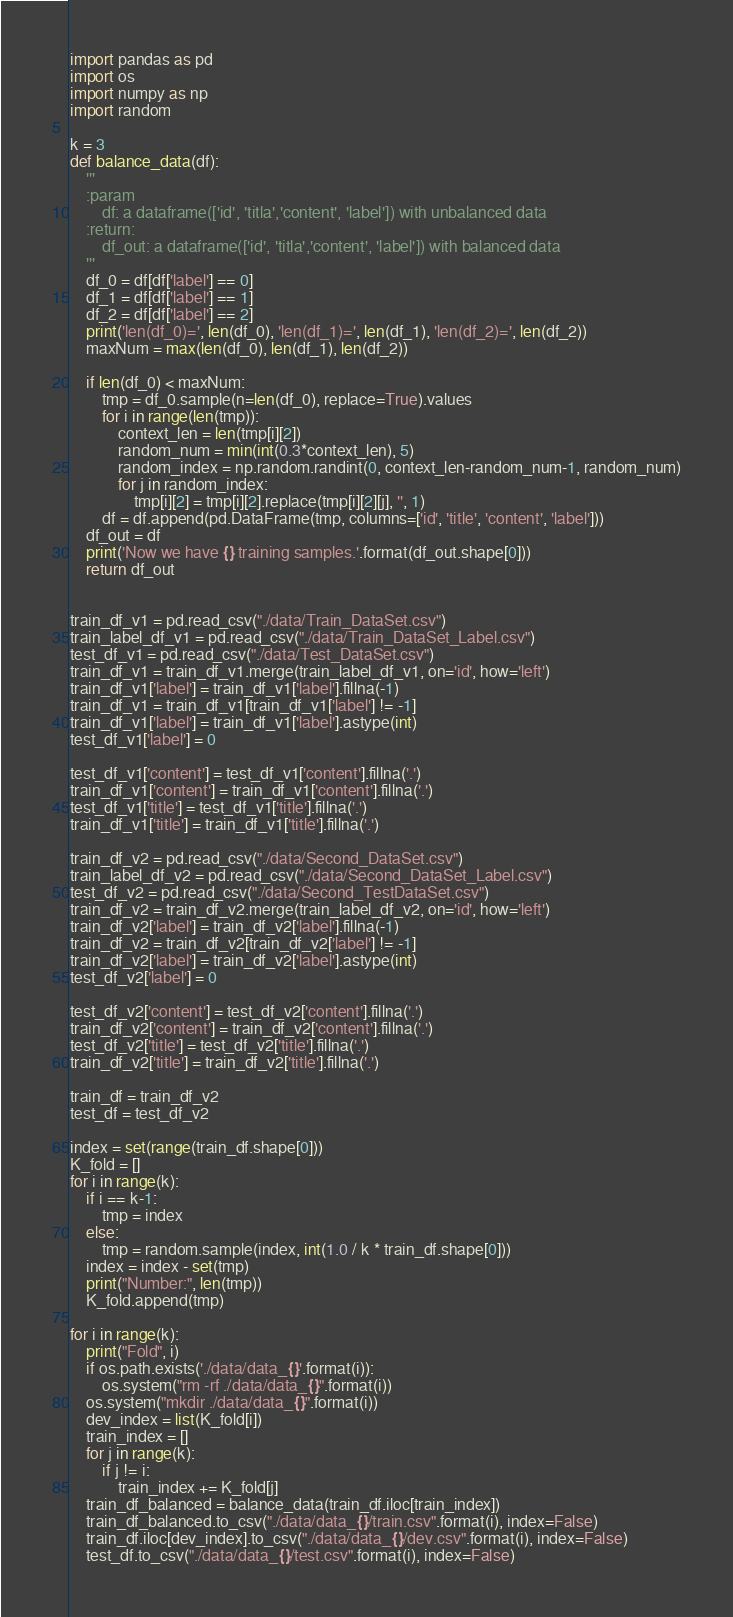<code> <loc_0><loc_0><loc_500><loc_500><_Python_>import pandas as pd
import os
import numpy as np
import random

k = 3
def balance_data(df):
    '''
    :param
        df: a dataframe(['id', 'titla','content', 'label']) with unbalanced data
    :return:
        df_out: a dataframe(['id', 'titla','content', 'label']) with balanced data
    '''
    df_0 = df[df['label'] == 0]
    df_1 = df[df['label'] == 1]
    df_2 = df[df['label'] == 2]
    print('len(df_0)=', len(df_0), 'len(df_1)=', len(df_1), 'len(df_2)=', len(df_2))
    maxNum = max(len(df_0), len(df_1), len(df_2))

    if len(df_0) < maxNum:
        tmp = df_0.sample(n=len(df_0), replace=True).values
        for i in range(len(tmp)):
            context_len = len(tmp[i][2])
            random_num = min(int(0.3*context_len), 5)
            random_index = np.random.randint(0, context_len-random_num-1, random_num)
            for j in random_index:
                tmp[i][2] = tmp[i][2].replace(tmp[i][2][j], '', 1)
        df = df.append(pd.DataFrame(tmp, columns=['id', 'title', 'content', 'label']))
    df_out = df
    print('Now we have {} training samples.'.format(df_out.shape[0]))
    return df_out


train_df_v1 = pd.read_csv("./data/Train_DataSet.csv")
train_label_df_v1 = pd.read_csv("./data/Train_DataSet_Label.csv")
test_df_v1 = pd.read_csv("./data/Test_DataSet.csv")
train_df_v1 = train_df_v1.merge(train_label_df_v1, on='id', how='left')
train_df_v1['label'] = train_df_v1['label'].fillna(-1)
train_df_v1 = train_df_v1[train_df_v1['label'] != -1]
train_df_v1['label'] = train_df_v1['label'].astype(int)
test_df_v1['label'] = 0

test_df_v1['content'] = test_df_v1['content'].fillna('.')
train_df_v1['content'] = train_df_v1['content'].fillna('.')
test_df_v1['title'] = test_df_v1['title'].fillna('.')
train_df_v1['title'] = train_df_v1['title'].fillna('.')

train_df_v2 = pd.read_csv("./data/Second_DataSet.csv")
train_label_df_v2 = pd.read_csv("./data/Second_DataSet_Label.csv")
test_df_v2 = pd.read_csv("./data/Second_TestDataSet.csv")
train_df_v2 = train_df_v2.merge(train_label_df_v2, on='id', how='left')
train_df_v2['label'] = train_df_v2['label'].fillna(-1)
train_df_v2 = train_df_v2[train_df_v2['label'] != -1]
train_df_v2['label'] = train_df_v2['label'].astype(int)
test_df_v2['label'] = 0

test_df_v2['content'] = test_df_v2['content'].fillna('.')
train_df_v2['content'] = train_df_v2['content'].fillna('.')
test_df_v2['title'] = test_df_v2['title'].fillna('.')
train_df_v2['title'] = train_df_v2['title'].fillna('.')

train_df = train_df_v2
test_df = test_df_v2

index = set(range(train_df.shape[0]))
K_fold = []
for i in range(k):
    if i == k-1:
        tmp = index
    else:
        tmp = random.sample(index, int(1.0 / k * train_df.shape[0]))
    index = index - set(tmp)
    print("Number:", len(tmp))
    K_fold.append(tmp)

for i in range(k):
    print("Fold", i)
    if os.path.exists('./data/data_{}'.format(i)):
        os.system("rm -rf ./data/data_{}".format(i))
    os.system("mkdir ./data/data_{}".format(i))
    dev_index = list(K_fold[i])
    train_index = []
    for j in range(k):
        if j != i:
            train_index += K_fold[j]
    train_df_balanced = balance_data(train_df.iloc[train_index])
    train_df_balanced.to_csv("./data/data_{}/train.csv".format(i), index=False)
    train_df.iloc[dev_index].to_csv("./data/data_{}/dev.csv".format(i), index=False)
    test_df.to_csv("./data/data_{}/test.csv".format(i), index=False)
</code> 